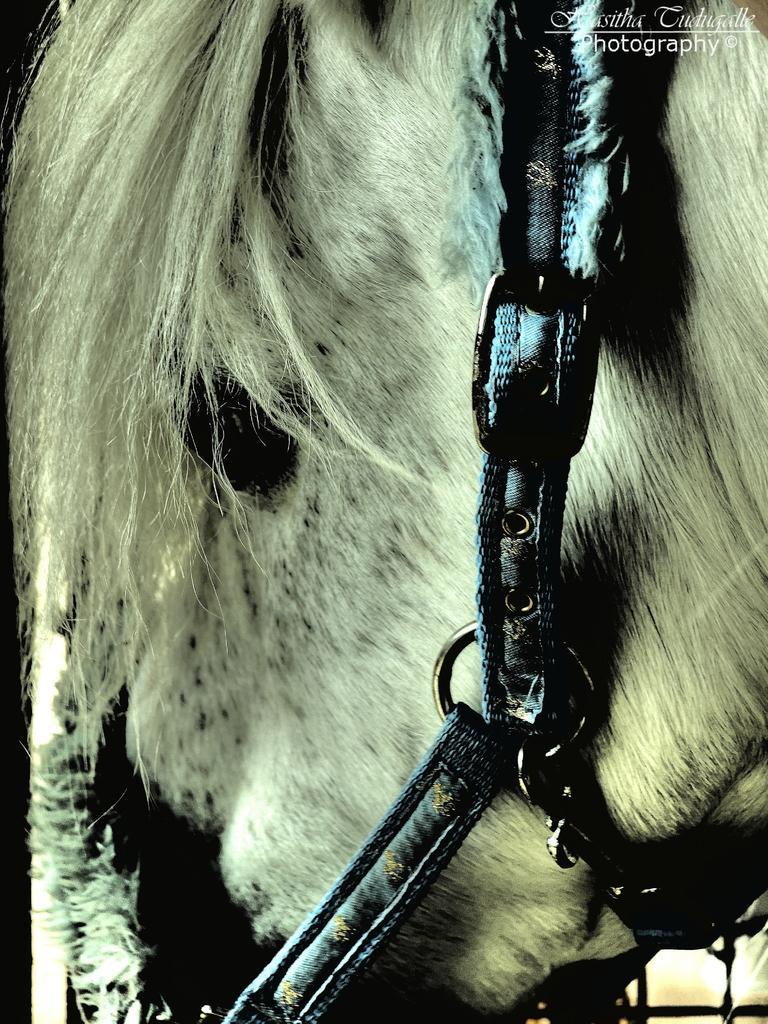How would you summarize this image in a sentence or two? In this image there is a horse tied with belts. 